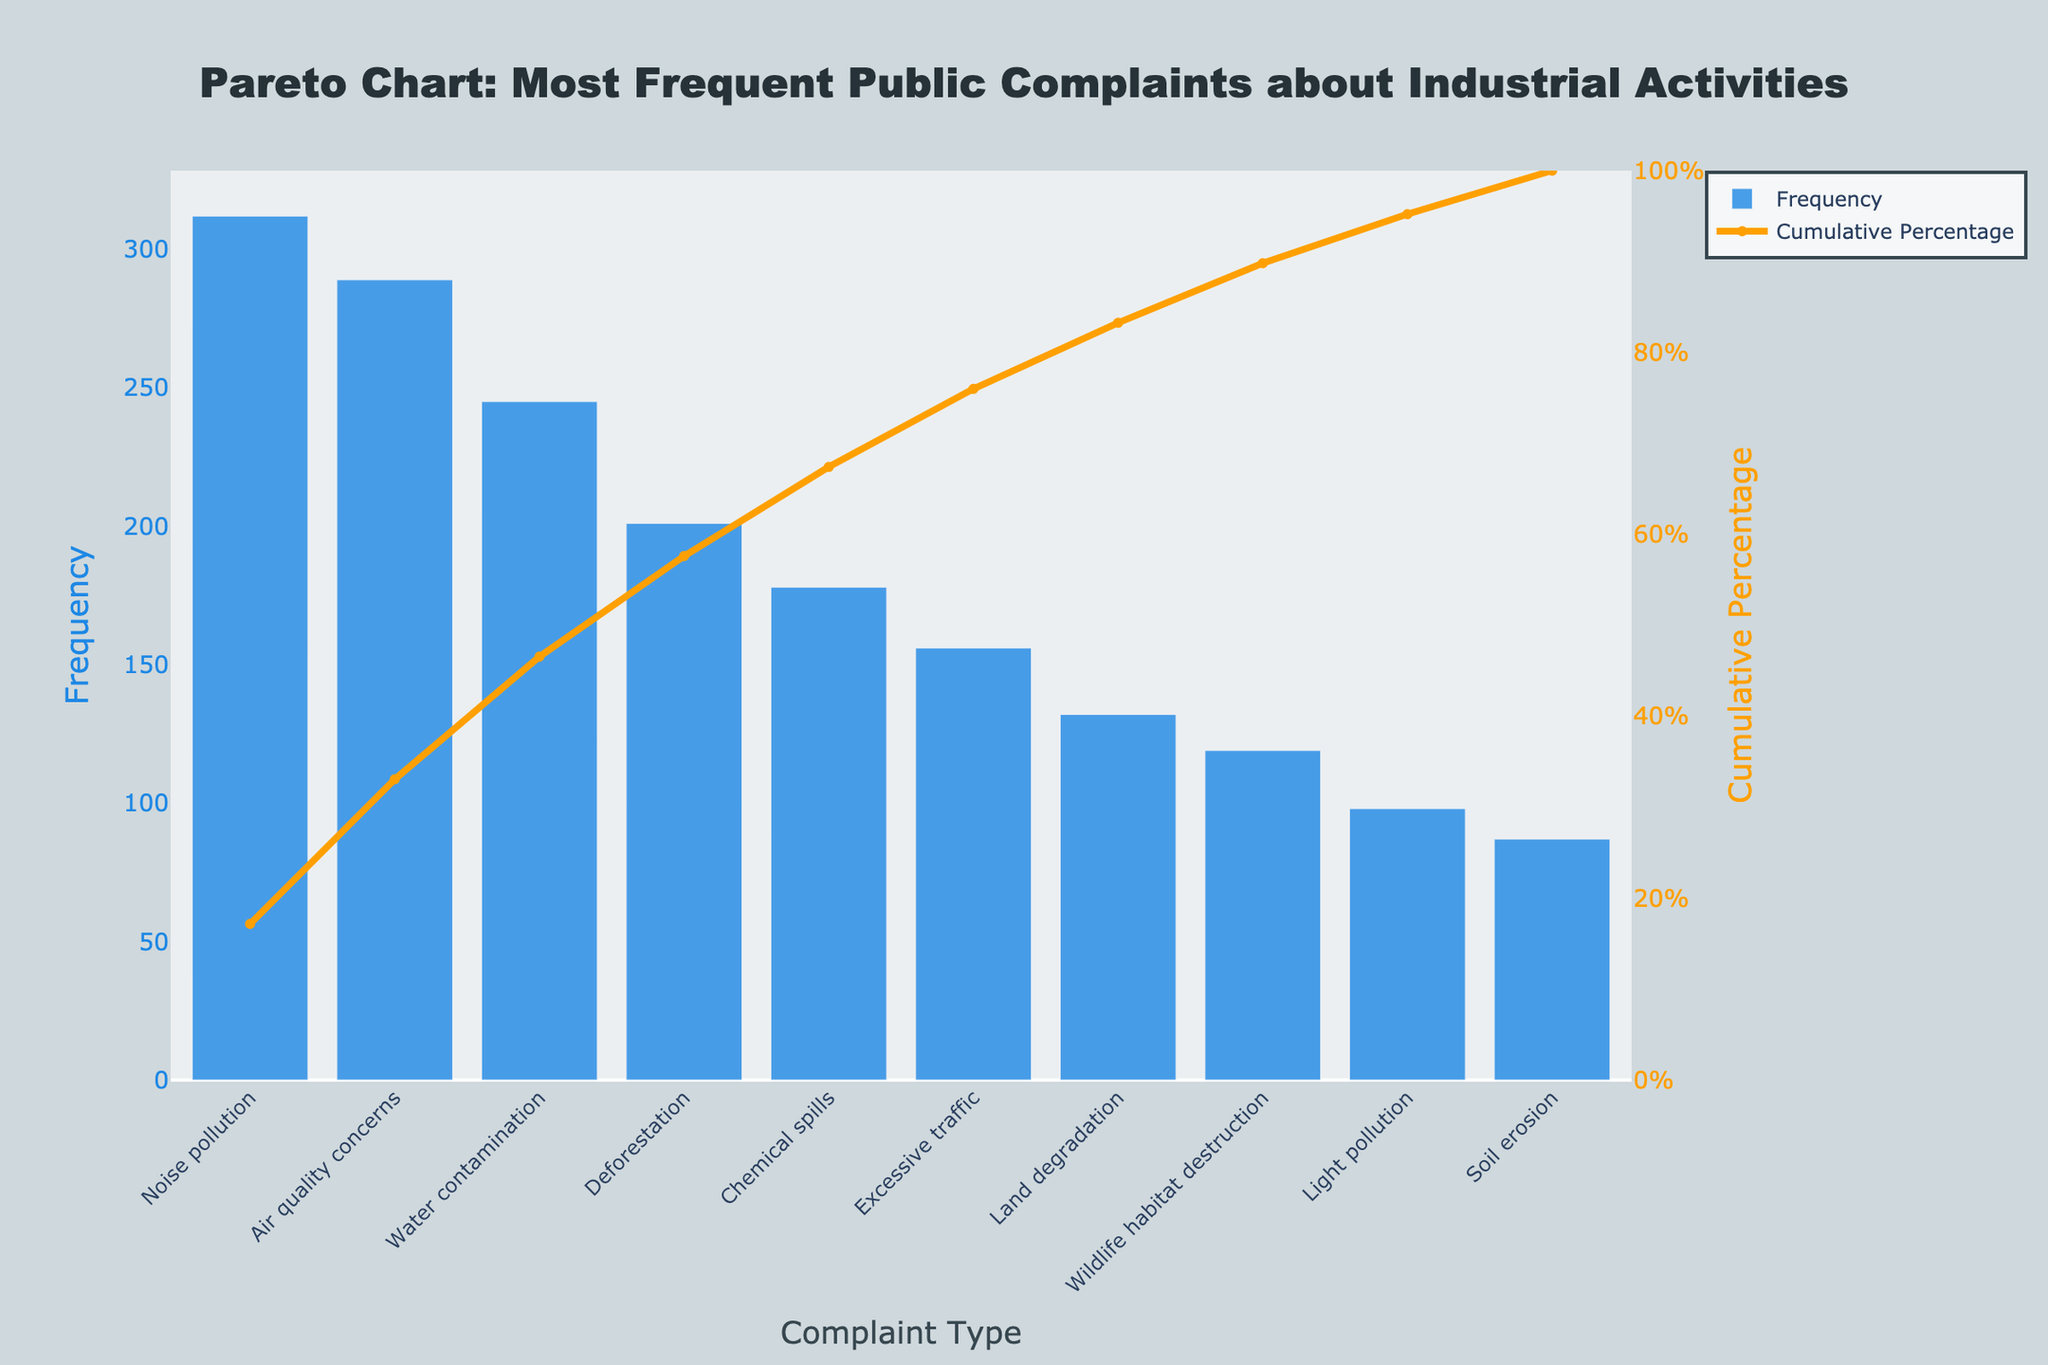What is the total number of complaints recorded? To find the total number of complaints, sum all the frequencies of each complaint type: 312 + 289 + 245 + 201 + 178 + 156 + 132 + 119 + 98 + 87.
Answer: 1817 What is the complaint with the highest frequency? The complaint with the highest frequency is positioned first in the bar chart and has the highest bar height.
Answer: Noise pollution What percentage of total complaints is accounted for by the top three complaints? First, sum the frequencies of the top three complaints: 312 (Noise pollution) + 289 (Air quality concerns) + 245 (Water contamination) = 846. Then, divide by the total number of complaints (1817) and multiply by 100: (846 / 1817) * 100 ≈ 46.56%.
Answer: Around 46.56% Which complaint type has the least frequency? The complaint with the least frequency has the shortest bar in the bar chart.
Answer: Soil erosion Which complaint types together make up approximately 80% of the total complaints? Examine the cumulative percentage line and find where it reaches approximately 80%. Track the corresponding complaint types at that point: noise pollution, air quality concerns, water contamination, deforestation, and chemical spills.
Answer: Noise pollution, Air quality concerns, Water contamination, Deforestation, Chemical spills By how much does the frequency of "Noise pollution" exceed that of "Excessive traffic"? Subtract the frequency of Excessive traffic from that of Noise pollution: 312 - 156 = 156.
Answer: 156 What is the cumulative percentage after including the top five complaints? Adding up the cumulative percentages of the top five complaints: Noise pollution (17.17%) + Air quality concerns (33.11%) + Water contamination (46.56%) + Deforestation (57.67%) + Chemical spills (67.47%) = 67.47%.
Answer: Around 67.47% How many complaint types individually have a frequency greater than 200? By inspecting the bar chart, count the number of bars with heights representing frequencies greater than 200: Noise pollution, Air quality concerns, Water contamination, and Deforestation.
Answer: 4 